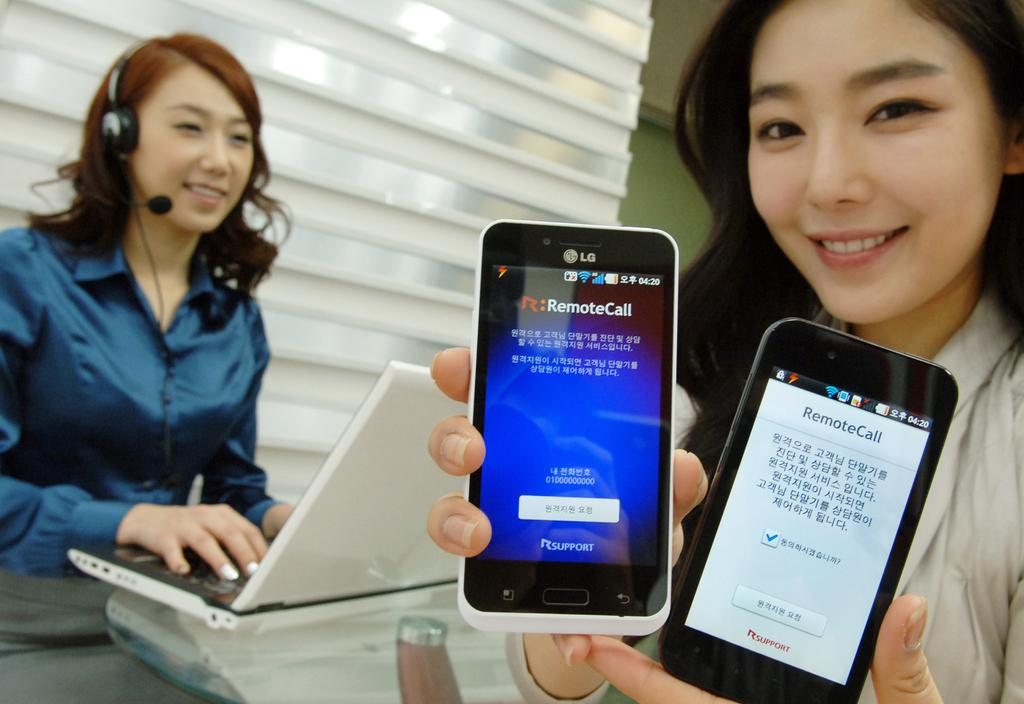Provide a one-sentence caption for the provided image. A woman is holding two cell phones which display RemoteCall on the screen. 